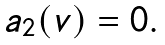<formula> <loc_0><loc_0><loc_500><loc_500>\begin{array} { c } a _ { 2 } ( v ) = 0 . \\ \end{array}</formula> 